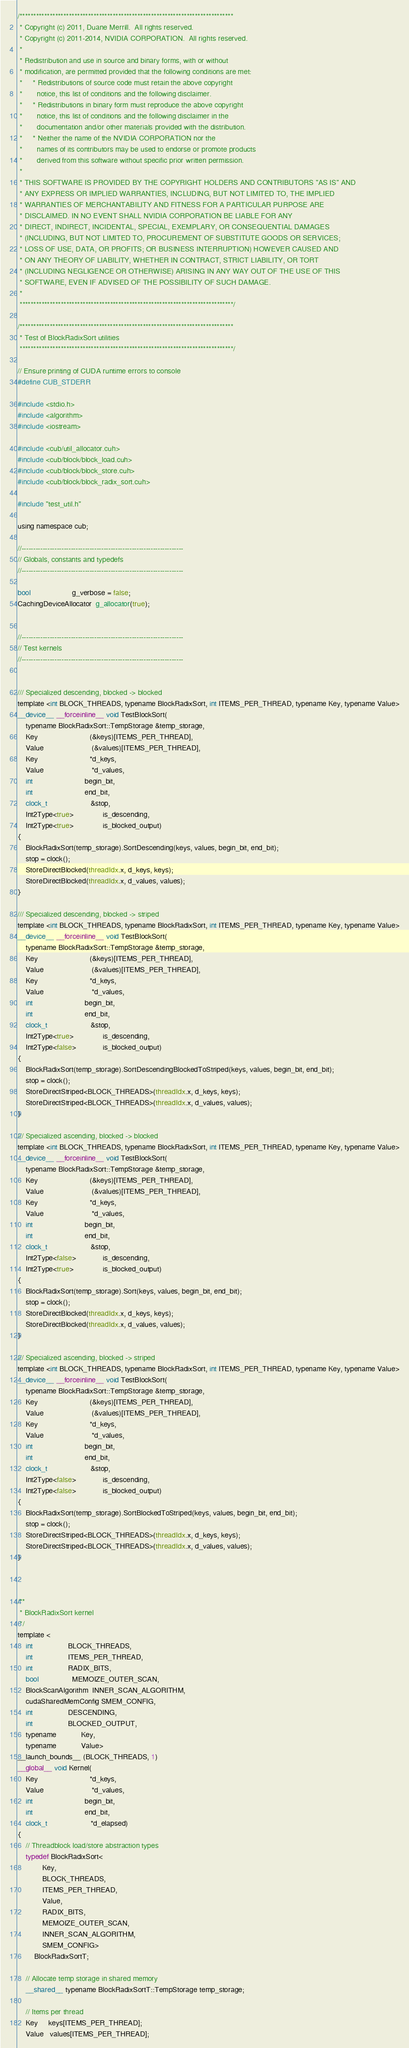<code> <loc_0><loc_0><loc_500><loc_500><_Cuda_>/******************************************************************************
 * Copyright (c) 2011, Duane Merrill.  All rights reserved.
 * Copyright (c) 2011-2014, NVIDIA CORPORATION.  All rights reserved.
 *
 * Redistribution and use in source and binary forms, with or without
 * modification, are permitted provided that the following conditions are met:
 *     * Redistributions of source code must retain the above copyright
 *       notice, this list of conditions and the following disclaimer.
 *     * Redistributions in binary form must reproduce the above copyright
 *       notice, this list of conditions and the following disclaimer in the
 *       documentation and/or other materials provided with the distribution.
 *     * Neither the name of the NVIDIA CORPORATION nor the
 *       names of its contributors may be used to endorse or promote products
 *       derived from this software without specific prior written permission.
 *
 * THIS SOFTWARE IS PROVIDED BY THE COPYRIGHT HOLDERS AND CONTRIBUTORS "AS IS" AND
 * ANY EXPRESS OR IMPLIED WARRANTIES, INCLUDING, BUT NOT LIMITED TO, THE IMPLIED
 * WARRANTIES OF MERCHANTABILITY AND FITNESS FOR A PARTICULAR PURPOSE ARE
 * DISCLAIMED. IN NO EVENT SHALL NVIDIA CORPORATION BE LIABLE FOR ANY
 * DIRECT, INDIRECT, INCIDENTAL, SPECIAL, EXEMPLARY, OR CONSEQUENTIAL DAMAGES
 * (INCLUDING, BUT NOT LIMITED TO, PROCUREMENT OF SUBSTITUTE GOODS OR SERVICES;
 * LOSS OF USE, DATA, OR PROFITS; OR BUSINESS INTERRUPTION) HOWEVER CAUSED AND
 * ON ANY THEORY OF LIABILITY, WHETHER IN CONTRACT, STRICT LIABILITY, OR TORT
 * (INCLUDING NEGLIGENCE OR OTHERWISE) ARISING IN ANY WAY OUT OF THE USE OF THIS
 * SOFTWARE, EVEN IF ADVISED OF THE POSSIBILITY OF SUCH DAMAGE.
 *
 ******************************************************************************/

/******************************************************************************
 * Test of BlockRadixSort utilities
 ******************************************************************************/

// Ensure printing of CUDA runtime errors to console
#define CUB_STDERR

#include <stdio.h>
#include <algorithm>
#include <iostream>

#include <cub/util_allocator.cuh>
#include <cub/block/block_load.cuh>
#include <cub/block/block_store.cuh>
#include <cub/block/block_radix_sort.cuh>

#include "test_util.h"

using namespace cub;

//---------------------------------------------------------------------
// Globals, constants and typedefs
//---------------------------------------------------------------------

bool                    g_verbose = false;
CachingDeviceAllocator  g_allocator(true);


//---------------------------------------------------------------------
// Test kernels
//---------------------------------------------------------------------


/// Specialized descending, blocked -> blocked
template <int BLOCK_THREADS, typename BlockRadixSort, int ITEMS_PER_THREAD, typename Key, typename Value>
__device__ __forceinline__ void TestBlockSort(
    typename BlockRadixSort::TempStorage &temp_storage,
    Key                         (&keys)[ITEMS_PER_THREAD],
    Value                       (&values)[ITEMS_PER_THREAD],
    Key                         *d_keys,
    Value                       *d_values,
    int                         begin_bit,
    int                         end_bit,
    clock_t                     &stop,
    Int2Type<true>              is_descending,
    Int2Type<true>              is_blocked_output)
{
    BlockRadixSort(temp_storage).SortDescending(keys, values, begin_bit, end_bit);
    stop = clock();
    StoreDirectBlocked(threadIdx.x, d_keys, keys);
    StoreDirectBlocked(threadIdx.x, d_values, values);
}

/// Specialized descending, blocked -> striped
template <int BLOCK_THREADS, typename BlockRadixSort, int ITEMS_PER_THREAD, typename Key, typename Value>
__device__ __forceinline__ void TestBlockSort(
    typename BlockRadixSort::TempStorage &temp_storage,
    Key                         (&keys)[ITEMS_PER_THREAD],
    Value                       (&values)[ITEMS_PER_THREAD],
    Key                         *d_keys,
    Value                       *d_values,
    int                         begin_bit,
    int                         end_bit,
    clock_t                     &stop,
    Int2Type<true>              is_descending,
    Int2Type<false>             is_blocked_output)
{
    BlockRadixSort(temp_storage).SortDescendingBlockedToStriped(keys, values, begin_bit, end_bit);
    stop = clock();
    StoreDirectStriped<BLOCK_THREADS>(threadIdx.x, d_keys, keys);
    StoreDirectStriped<BLOCK_THREADS>(threadIdx.x, d_values, values);
}

/// Specialized ascending, blocked -> blocked
template <int BLOCK_THREADS, typename BlockRadixSort, int ITEMS_PER_THREAD, typename Key, typename Value>
__device__ __forceinline__ void TestBlockSort(
    typename BlockRadixSort::TempStorage &temp_storage,
    Key                         (&keys)[ITEMS_PER_THREAD],
    Value                       (&values)[ITEMS_PER_THREAD],
    Key                         *d_keys,
    Value                       *d_values,
    int                         begin_bit,
    int                         end_bit,
    clock_t                     &stop,
    Int2Type<false>             is_descending,
    Int2Type<true>              is_blocked_output)
{
    BlockRadixSort(temp_storage).Sort(keys, values, begin_bit, end_bit);
    stop = clock();
    StoreDirectBlocked(threadIdx.x, d_keys, keys);
    StoreDirectBlocked(threadIdx.x, d_values, values);
}

/// Specialized ascending, blocked -> striped
template <int BLOCK_THREADS, typename BlockRadixSort, int ITEMS_PER_THREAD, typename Key, typename Value>
__device__ __forceinline__ void TestBlockSort(
    typename BlockRadixSort::TempStorage &temp_storage,
    Key                         (&keys)[ITEMS_PER_THREAD],
    Value                       (&values)[ITEMS_PER_THREAD],
    Key                         *d_keys,
    Value                       *d_values,
    int                         begin_bit,
    int                         end_bit,
    clock_t                     &stop,
    Int2Type<false>             is_descending,
    Int2Type<false>             is_blocked_output)
{
    BlockRadixSort(temp_storage).SortBlockedToStriped(keys, values, begin_bit, end_bit);
    stop = clock();
    StoreDirectStriped<BLOCK_THREADS>(threadIdx.x, d_keys, keys);
    StoreDirectStriped<BLOCK_THREADS>(threadIdx.x, d_values, values);
}



/**
 * BlockRadixSort kernel
 */
template <
    int                 BLOCK_THREADS,
    int                 ITEMS_PER_THREAD,
    int                 RADIX_BITS,
    bool                MEMOIZE_OUTER_SCAN,
    BlockScanAlgorithm  INNER_SCAN_ALGORITHM,
    cudaSharedMemConfig SMEM_CONFIG,
    int                 DESCENDING,
    int                 BLOCKED_OUTPUT,
    typename            Key,
    typename            Value>
__launch_bounds__ (BLOCK_THREADS, 1)
__global__ void Kernel(
    Key                         *d_keys,
    Value                       *d_values,
    int                         begin_bit,
    int                         end_bit,
    clock_t                     *d_elapsed)
{
    // Threadblock load/store abstraction types
    typedef BlockRadixSort<
            Key,
            BLOCK_THREADS,
            ITEMS_PER_THREAD,
            Value,
            RADIX_BITS,
            MEMOIZE_OUTER_SCAN,
            INNER_SCAN_ALGORITHM,
            SMEM_CONFIG>
        BlockRadixSortT;

    // Allocate temp storage in shared memory
    __shared__ typename BlockRadixSortT::TempStorage temp_storage;

    // Items per thread
    Key     keys[ITEMS_PER_THREAD];
    Value   values[ITEMS_PER_THREAD];
</code> 